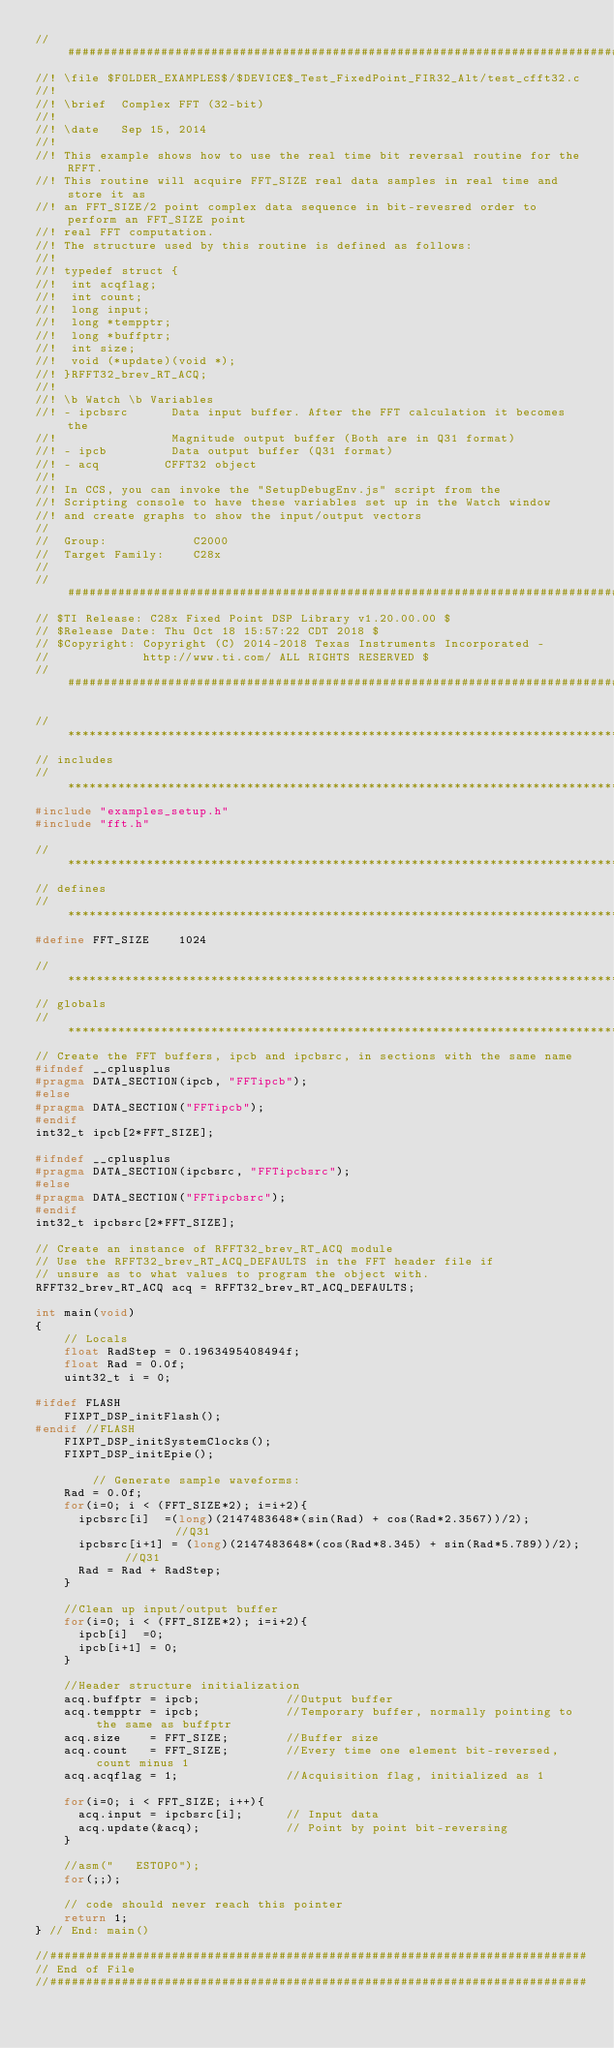<code> <loc_0><loc_0><loc_500><loc_500><_C_>//#############################################################################
//! \file $FOLDER_EXAMPLES$/$DEVICE$_Test_FixedPoint_FIR32_Alt/test_cfft32.c
//!
//! \brief  Complex FFT (32-bit)
//!
//! \date   Sep 15, 2014
//! 
//! This example shows how to use the real time bit reversal routine for the RFFT.
//! This routine will acquire FFT_SIZE real data samples in real time and store it as 
//! an FFT_SIZE/2 point complex data sequence in bit-revesred order to perform an FFT_SIZE point
//! real FFT computation.
//! The structure used by this routine is defined as follows:
//! 
//! typedef struct {
//!  int acqflag;
//!  int count;
//!  long input; 
//!  long *tempptr;
//!  long *buffptr;
//!  int size;
//!  void (*update)(void *); 
//! }RFFT32_brev_RT_ACQ; 
//! 
//! \b Watch \b Variables
//! - ipcbsrc      Data input buffer. After the FFT calculation it becomes the 
//!                Magnitude output buffer (Both are in Q31 format)
//! - ipcb         Data output buffer (Q31 format)
//! - acq         CFFT32 object
//! 
//! In CCS, you can invoke the "SetupDebugEnv.js" script from the 
//! Scripting console to have these variables set up in the Watch window
//! and create graphs to show the input/output vectors
//
//  Group:            C2000
//  Target Family:    C28x
//
//#############################################################################
// $TI Release: C28x Fixed Point DSP Library v1.20.00.00 $
// $Release Date: Thu Oct 18 15:57:22 CDT 2018 $
// $Copyright: Copyright (C) 2014-2018 Texas Instruments Incorporated -
//             http://www.ti.com/ ALL RIGHTS RESERVED $
//#############################################################################

//*****************************************************************************
// includes
//*****************************************************************************
#include "examples_setup.h"
#include "fft.h"
   
//*****************************************************************************
// defines
//*****************************************************************************
#define FFT_SIZE    1024

//*****************************************************************************
// globals
//***************************************************************************** 
// Create the FFT buffers, ipcb and ipcbsrc, in sections with the same name
#ifndef __cplusplus
#pragma DATA_SECTION(ipcb, "FFTipcb");
#else
#pragma DATA_SECTION("FFTipcb");
#endif
int32_t ipcb[2*FFT_SIZE];

#ifndef __cplusplus
#pragma DATA_SECTION(ipcbsrc, "FFTipcbsrc");
#else
#pragma DATA_SECTION("FFTipcbsrc");
#endif
int32_t ipcbsrc[2*FFT_SIZE];

// Create an instance of RFFT32_brev_RT_ACQ module
// Use the RFFT32_brev_RT_ACQ_DEFAULTS in the FFT header file if
// unsure as to what values to program the object with.
RFFT32_brev_RT_ACQ acq = RFFT32_brev_RT_ACQ_DEFAULTS;

int main(void)
{    
    // Locals
    float RadStep = 0.1963495408494f;
    float Rad = 0.0f;
    uint32_t i = 0;
         
#ifdef FLASH
    FIXPT_DSP_initFlash();
#endif //FLASH
    FIXPT_DSP_initSystemClocks();
    FIXPT_DSP_initEpie();

        // Generate sample waveforms:
    Rad = 0.0f;
    for(i=0; i < (FFT_SIZE*2); i=i+2){
      ipcbsrc[i]  =(long)(2147483648*(sin(Rad) + cos(Rad*2.3567))/2);          //Q31
      ipcbsrc[i+1] = (long)(2147483648*(cos(Rad*8.345) + sin(Rad*5.789))/2);   //Q31
      Rad = Rad + RadStep;
    }

    //Clean up input/output buffer
    for(i=0; i < (FFT_SIZE*2); i=i+2){
      ipcb[i]  =0;          
      ipcb[i+1] = 0;    
    }

    //Header structure initialization
    acq.buffptr = ipcb;            //Output buffer
    acq.tempptr = ipcb;            //Temporary buffer, normally pointing to the same as buffptr
    acq.size    = FFT_SIZE;        //Buffer size
    acq.count   = FFT_SIZE;        //Every time one element bit-reversed, count minus 1
    acq.acqflag = 1;               //Acquisition flag, initialized as 1
    
    for(i=0; i < FFT_SIZE; i++){
      acq.input = ipcbsrc[i];      // Input data
      acq.update(&acq);            // Point by point bit-reversing
    }        

    //asm("   ESTOP0");
    for(;;);
    
    // code should never reach this pointer
    return 1;
} // End: main()

//###########################################################################
// End of File
//###########################################################################
</code> 